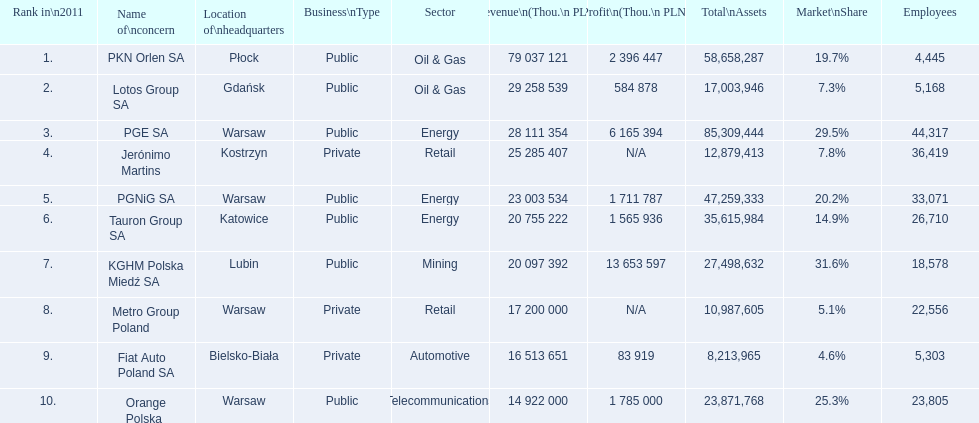What are the names of the major companies of poland? PKN Orlen SA, Lotos Group SA, PGE SA, Jerónimo Martins, PGNiG SA, Tauron Group SA, KGHM Polska Miedź SA, Metro Group Poland, Fiat Auto Poland SA, Orange Polska. What are the revenues of those companies in thou. pln? PKN Orlen SA, 79 037 121, Lotos Group SA, 29 258 539, PGE SA, 28 111 354, Jerónimo Martins, 25 285 407, PGNiG SA, 23 003 534, Tauron Group SA, 20 755 222, KGHM Polska Miedź SA, 20 097 392, Metro Group Poland, 17 200 000, Fiat Auto Poland SA, 16 513 651, Orange Polska, 14 922 000. Which of these revenues is greater than 75 000 000 thou. pln? 79 037 121. Which company has a revenue equal to 79 037 121 thou pln? PKN Orlen SA. 